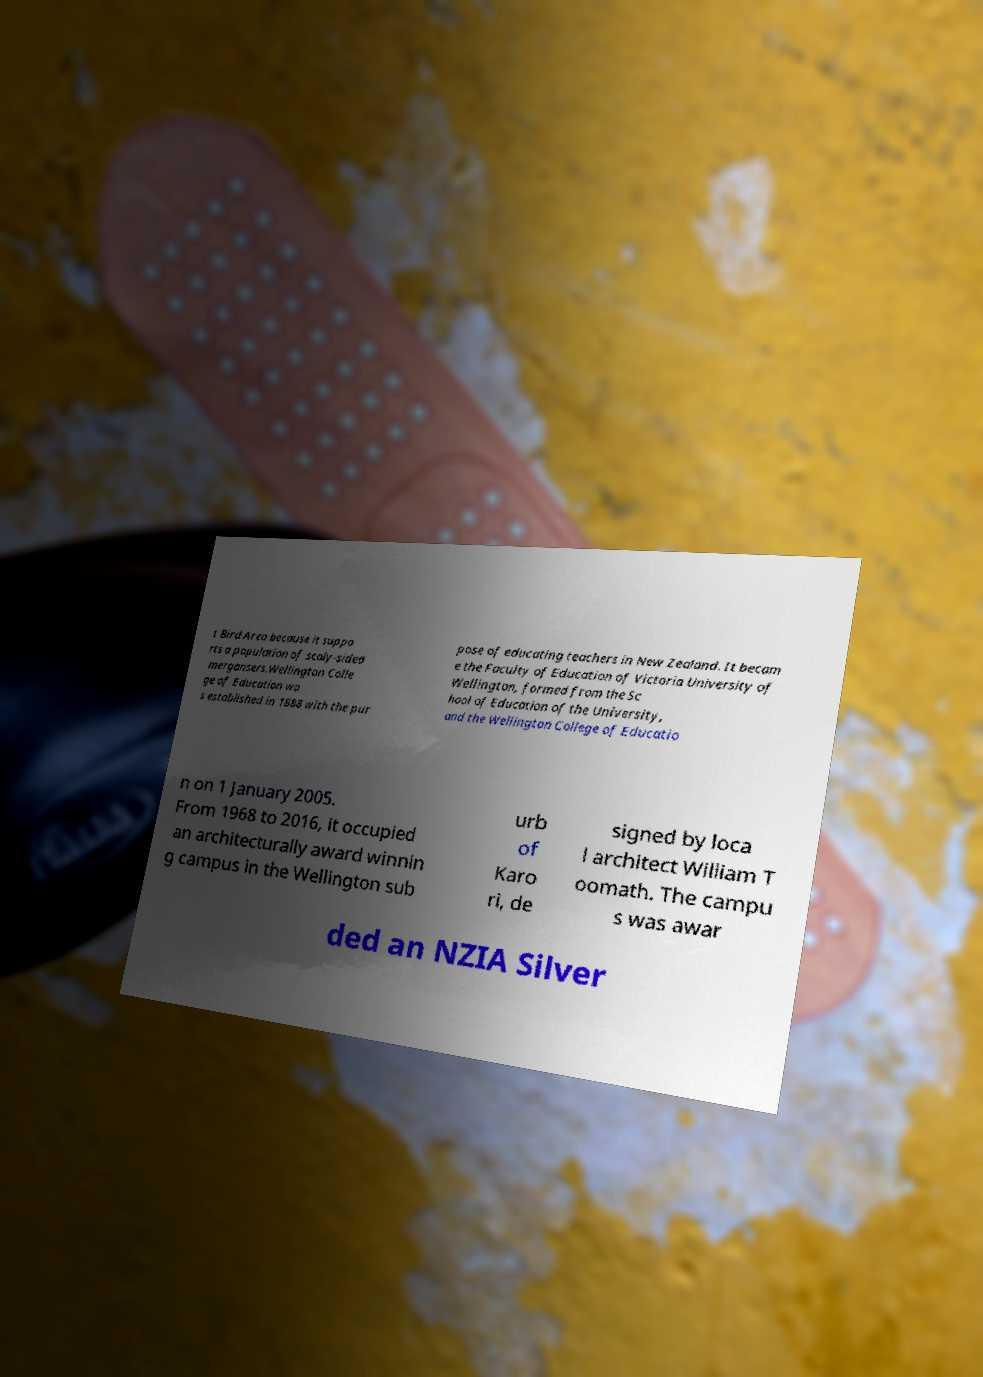There's text embedded in this image that I need extracted. Can you transcribe it verbatim? t Bird Area because it suppo rts a population of scaly-sided mergansers.Wellington Colle ge of Education wa s established in 1888 with the pur pose of educating teachers in New Zealand. It becam e the Faculty of Education of Victoria University of Wellington, formed from the Sc hool of Education of the University, and the Wellington College of Educatio n on 1 January 2005. From 1968 to 2016, it occupied an architecturally award winnin g campus in the Wellington sub urb of Karo ri, de signed by loca l architect William T oomath. The campu s was awar ded an NZIA Silver 